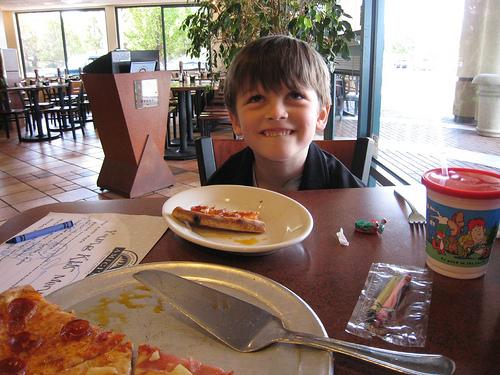What food is left on his plate?
Give a very brief answer. Pizza. How many pieces has he already had?
Answer briefly. 1. IS the boy happy?
Short answer required. Yes. Does the boy have a drink?
Keep it brief. Yes. Is the boy hungry?
Keep it brief. Yes. Is the boy laughing?
Answer briefly. Yes. What is the food sitting on?
Concise answer only. Plate. Is the child a boy or a girl?
Be succinct. Boy. What color bowl is on the floor?
Concise answer only. White. Is the child looking up?
Give a very brief answer. Yes. 